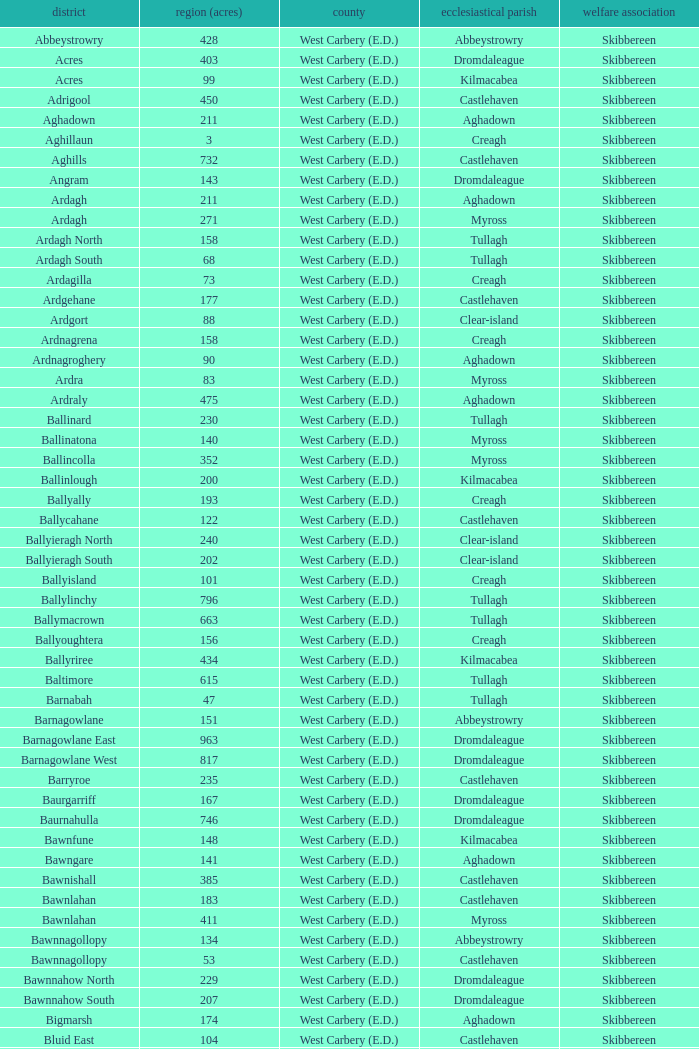What is the greatest area when the Poor Law Union is Skibbereen and the Civil Parish is Tullagh? 796.0. 